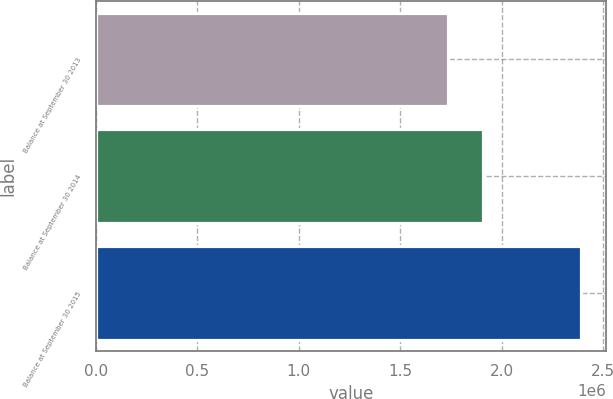Convert chart. <chart><loc_0><loc_0><loc_500><loc_500><bar_chart><fcel>Balance at September 30 2013<fcel>Balance at September 30 2014<fcel>Balance at September 30 2015<nl><fcel>1.73452e+06<fcel>1.90626e+06<fcel>2.39241e+06<nl></chart> 